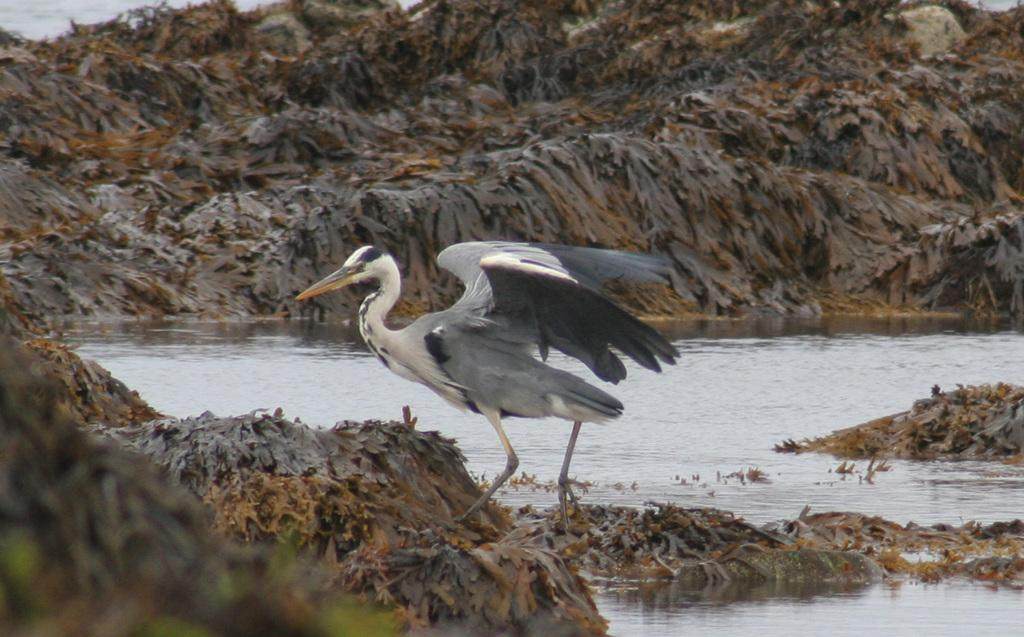What is the main subject of the picture? The main subject of the picture is a crane. Can you describe the color of the crane? The crane is white and black in color. What else can be seen in the picture besides the crane? There is water visible in the picture. What type of plate is being used to measure the degree of dust in the image? There is no plate or measurement of dust present in the image; it features a crane and water. 